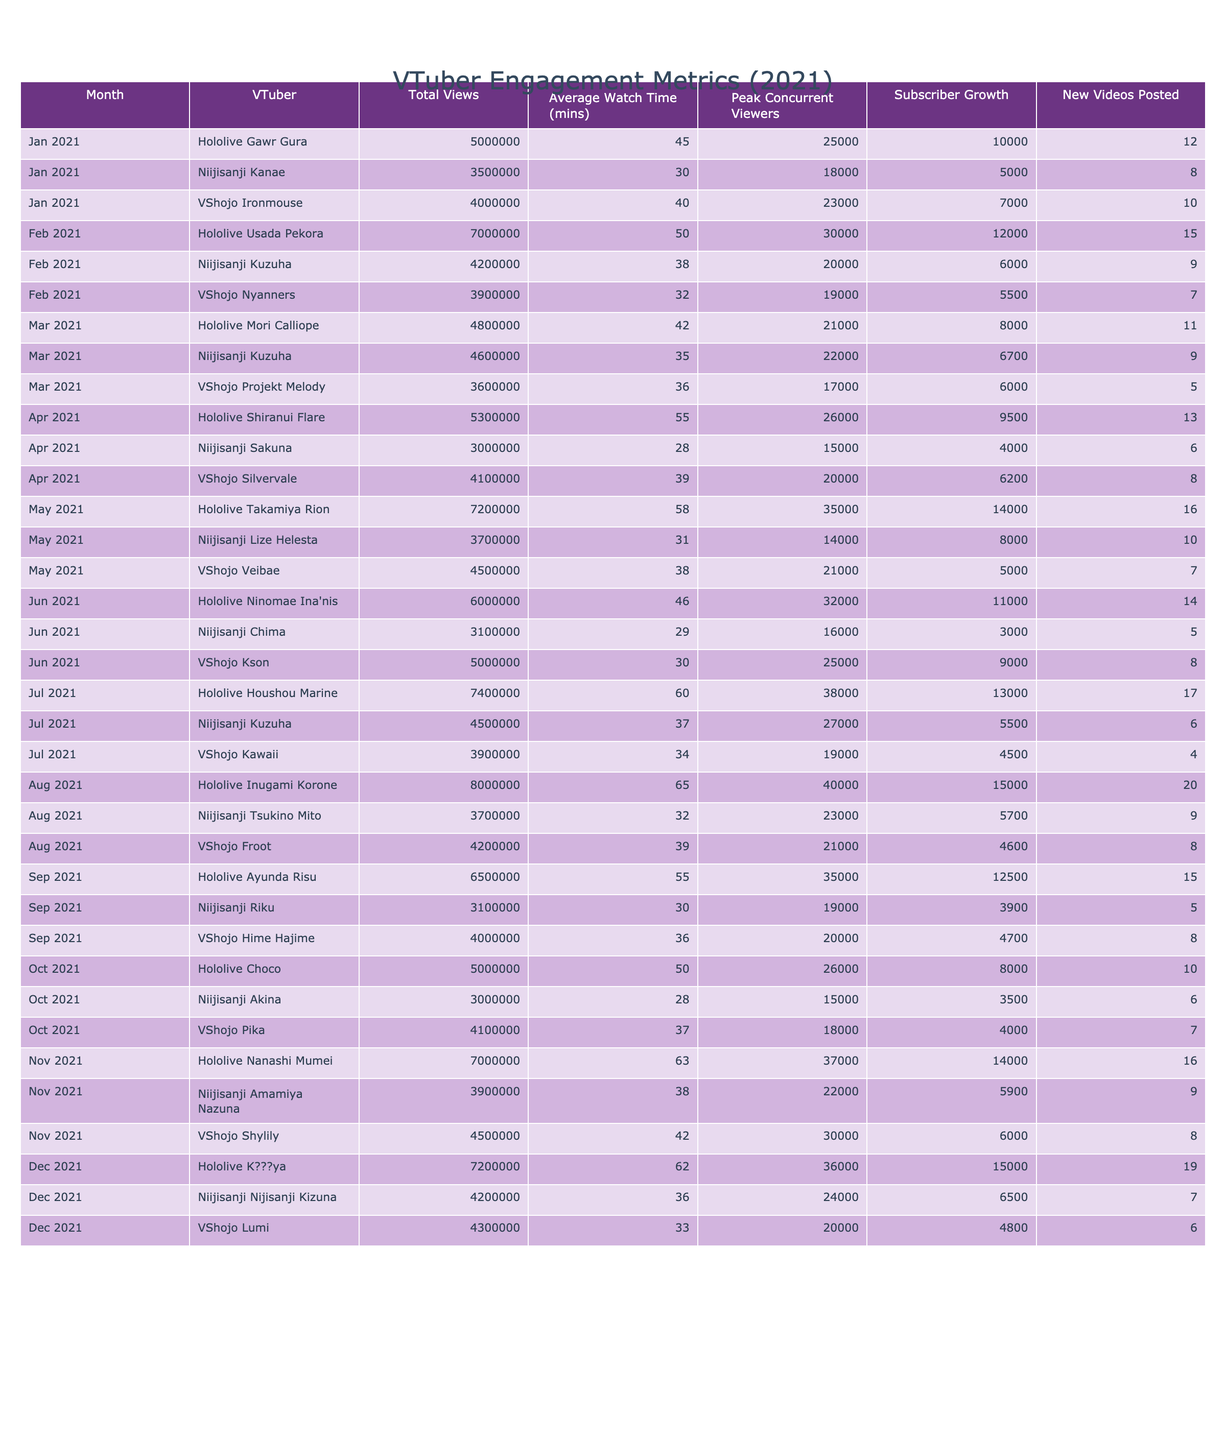What was the total views for Hololive Gawr Gura in January? According to the table, Hololive Gawr Gura's total views in January were explicitly listed as 5,000,000.
Answer: 5,000,000 Which VTuber had the highest average watch time in June? By reviewing the June data, Hololive Ninomae Ina'nis had an average watch time of 46 minutes, which is the highest compared to the other VTubers for that month.
Answer: Hololive Ninomae Ina'nis What was the subscriber growth for VShojo Ironmouse in January? The table shows that VShojo Ironmouse had a subscriber growth of 7,000 in January.
Answer: 7,000 Which month saw the most new videos posted by Hololive VTubers? By looking at the new videos posted by Hololive VTubers, August has the highest number with 20 new videos.
Answer: August Calculate the average total views for Niijisanji Kuzuha across all months in 2021. Niijisanji Kuzuha had total views of 4,200,000 in February, 4,600,000 in March, 4,500,000 in July. Therefore, the average is (4,200,000 + 4,600,000 + 4,500,000) / 3 = 4,466,667.
Answer: 4,466,667 Did VShojo Kson post more videos than Niijisanji Chima in June? In June, VShojo Kson posted 8 videos while Niijisanji Chima posted 5 videos. Thus, the statement is true.
Answer: Yes Which VTuber had the highest peak concurrent viewers in May? Hololive Takamiya Rion reached 35,000 peak concurrent viewers in May, which is the highest for that month.
Answer: Hololive Takamiya Rion Compare the total views of VShojo Ironmouse in January and VShojo Nyanners in February. Which one was higher? VShojo Ironmouse had 4,000,000 views in January and VShojo Nyanners had 3,900,000 views in February. Since 4,000,000 is greater than 3,900,000, Ironmouse had the higher total views.
Answer: VShojo Ironmouse What was the difference in average watch time between the top and bottom VTuber in December? The highest average watch time in December belonged to Hololive K???ya (62 mins), and the lowest to VShojo Lumi (33 mins). The difference is 62 - 33 = 29 minutes.
Answer: 29 minutes Was there a VTuber posted more videos than both Hololive and Niijisanji in April? Hololive Shiranui Flare posted 13 videos and Niijisanji Sakuna posted 6 videos in April. No other VTuber listed exceeds this number, making it false.
Answer: No 